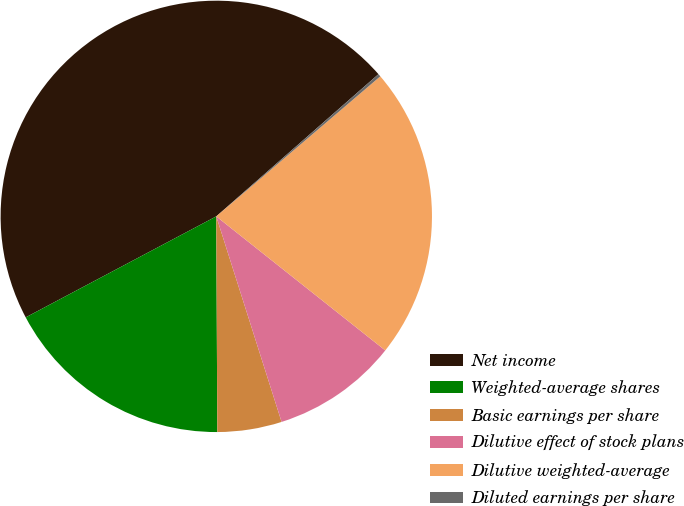Convert chart. <chart><loc_0><loc_0><loc_500><loc_500><pie_chart><fcel>Net income<fcel>Weighted-average shares<fcel>Basic earnings per share<fcel>Dilutive effect of stock plans<fcel>Dilutive weighted-average<fcel>Diluted earnings per share<nl><fcel>46.3%<fcel>17.32%<fcel>4.82%<fcel>9.43%<fcel>21.92%<fcel>0.21%<nl></chart> 